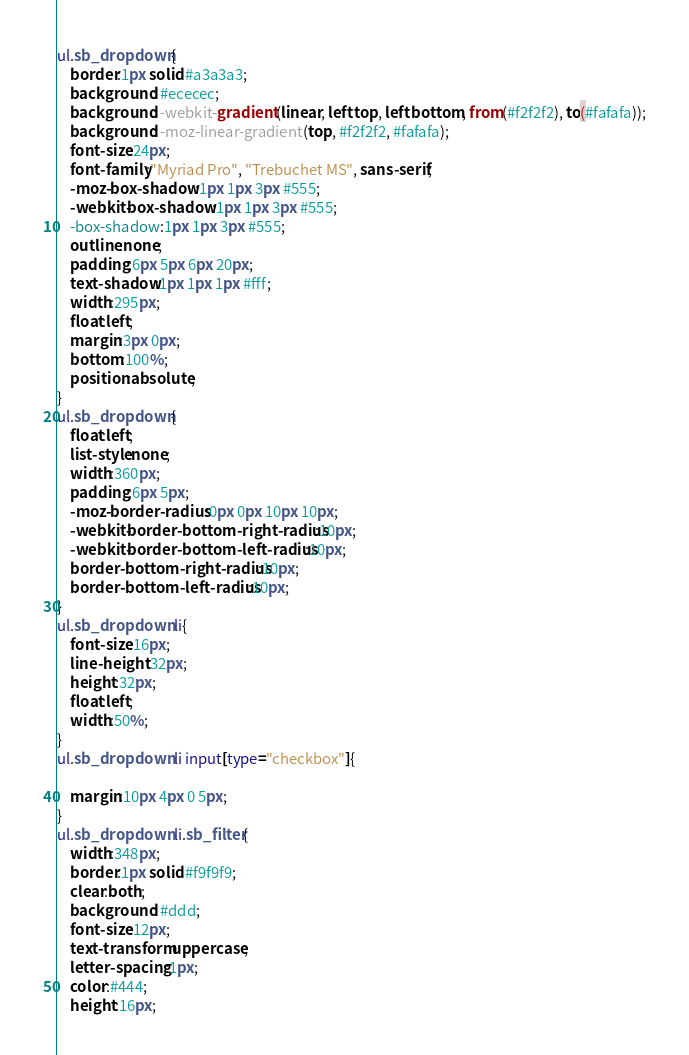<code> <loc_0><loc_0><loc_500><loc_500><_CSS_>ul.sb_dropdown{
    border:1px solid #a3a3a3;
    background: #ececec;
    background: -webkit-gradient(linear, left top, left bottom, from(#f2f2f2), to(#fafafa));
    background: -moz-linear-gradient(top, #f2f2f2, #fafafa);
    font-size:24px;
    font-family:"Myriad Pro", "Trebuchet MS", sans-serif;
    -moz-box-shadow:1px 1px 3px #555;
    -webkit-box-shadow:1px 1px 3px #555;
    -box-shadow:1px 1px 3px #555;
    outline:none;
    padding:6px 5px 6px 20px;
    text-shadow:1px 1px 1px #fff;
    width:295px;
    float:left;
    margin:3px 0px;
    bottom:100%;
    position:absolute;
}
ul.sb_dropdown{
    float:left;
    list-style:none;
    width:360px;
    padding:6px 5px;
    -moz-border-radius:0px 0px 10px 10px;
    -webkit-border-bottom-right-radius:10px;
    -webkit-border-bottom-left-radius:10px;
    border-bottom-right-radius:10px;
    border-bottom-left-radius:10px;
}
ul.sb_dropdown li{
    font-size:16px;
    line-height:32px;
    height:32px;
    float:left;
    width:50%;
}
ul.sb_dropdown li input[type="checkbox"]{

    margin:10px 4px 0 5px;
}
ul.sb_dropdown li.sb_filter{
    width:348px;
    border:1px solid #f9f9f9;
    clear:both;
    background: #ddd;
    font-size:12px;
    text-transform:uppercase;
    letter-spacing:1px;
    color:#444;
    height:16px;</code> 